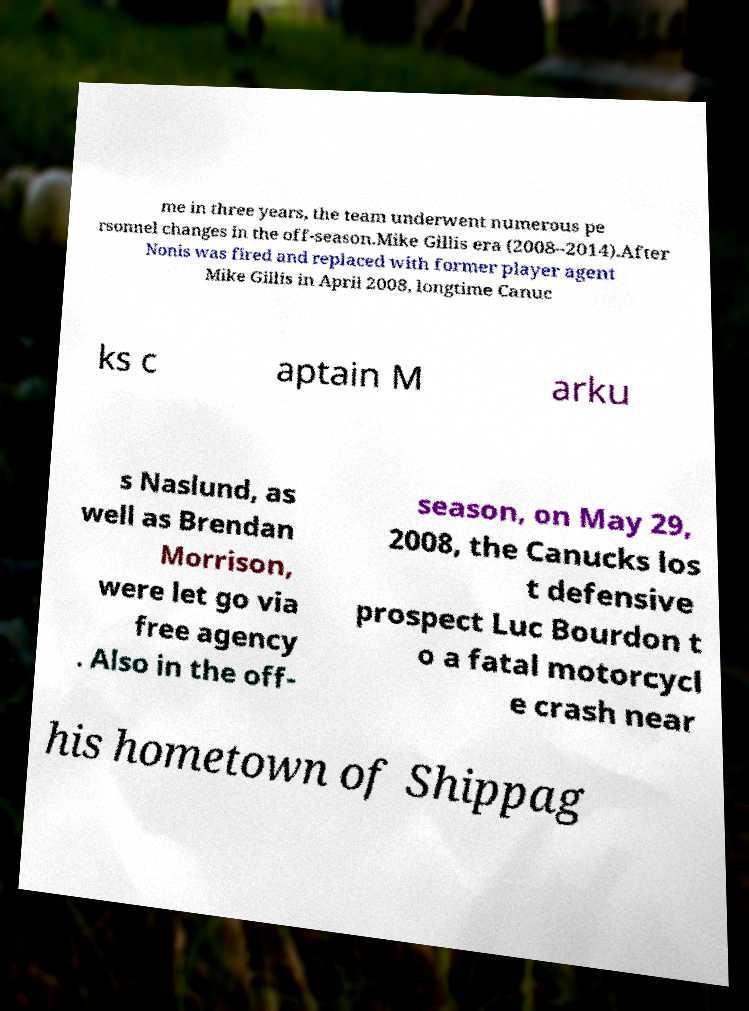Could you assist in decoding the text presented in this image and type it out clearly? me in three years, the team underwent numerous pe rsonnel changes in the off-season.Mike Gillis era (2008–2014).After Nonis was fired and replaced with former player agent Mike Gillis in April 2008, longtime Canuc ks c aptain M arku s Naslund, as well as Brendan Morrison, were let go via free agency . Also in the off- season, on May 29, 2008, the Canucks los t defensive prospect Luc Bourdon t o a fatal motorcycl e crash near his hometown of Shippag 